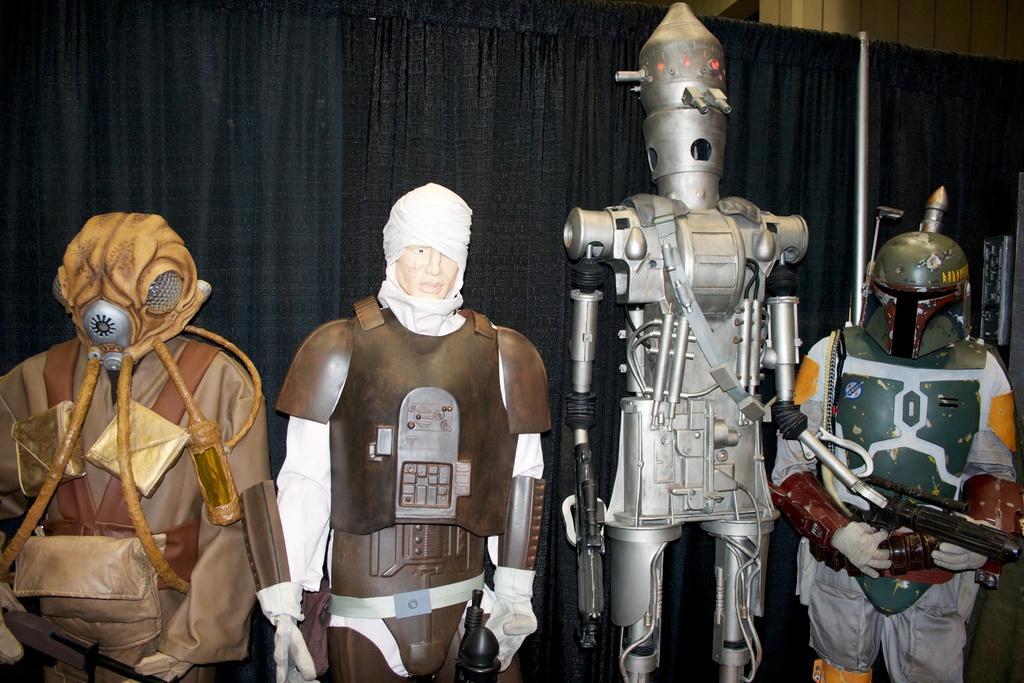Describe this image in one or two sentences. In this image there is a figurine truncated towards the bottom of the image, at the background of the image there are curtains truncated, at the top of the image there is a wall truncated. 